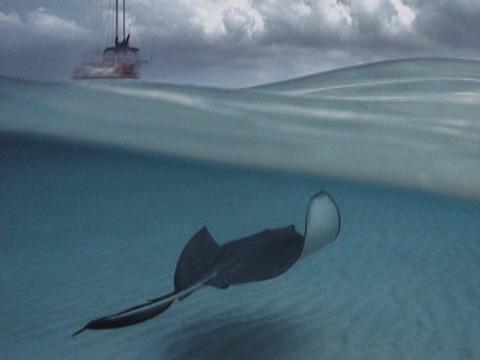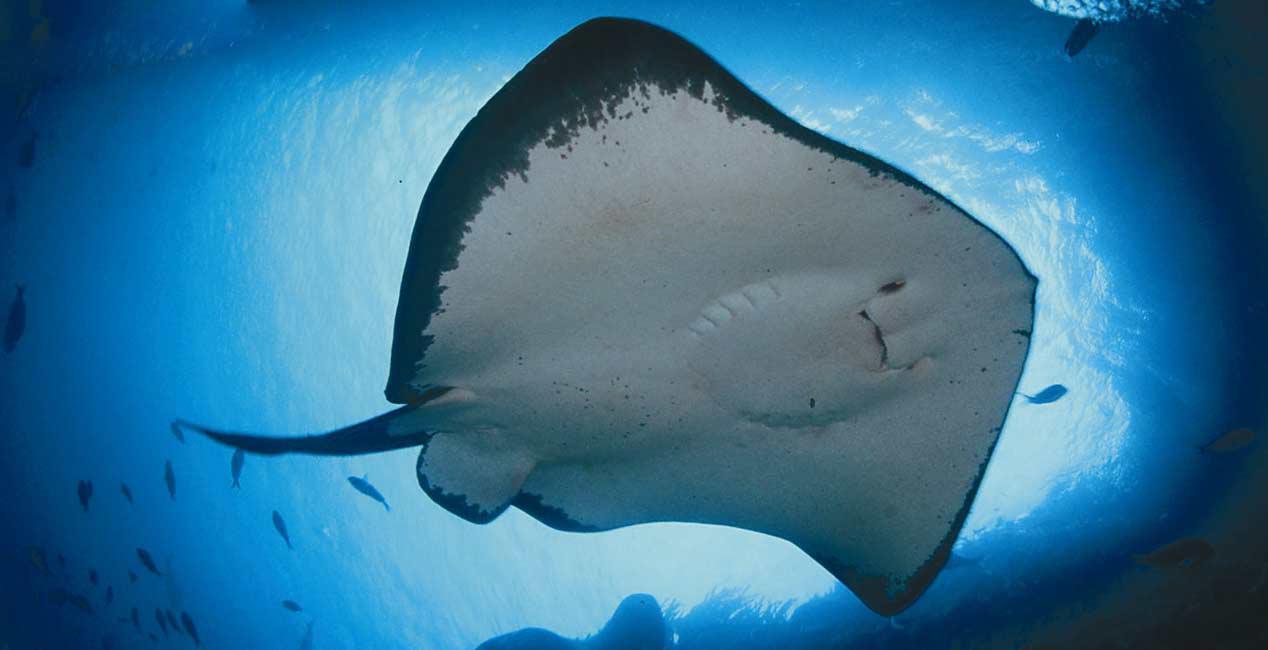The first image is the image on the left, the second image is the image on the right. Considering the images on both sides, is "Right image shows the underbelly of a stingray, and the left shows a top-view of a stingray near the ocean bottom." valid? Answer yes or no. Yes. The first image is the image on the left, the second image is the image on the right. Analyze the images presented: Is the assertion "The top of the ray in the image on the left is visible." valid? Answer yes or no. Yes. 